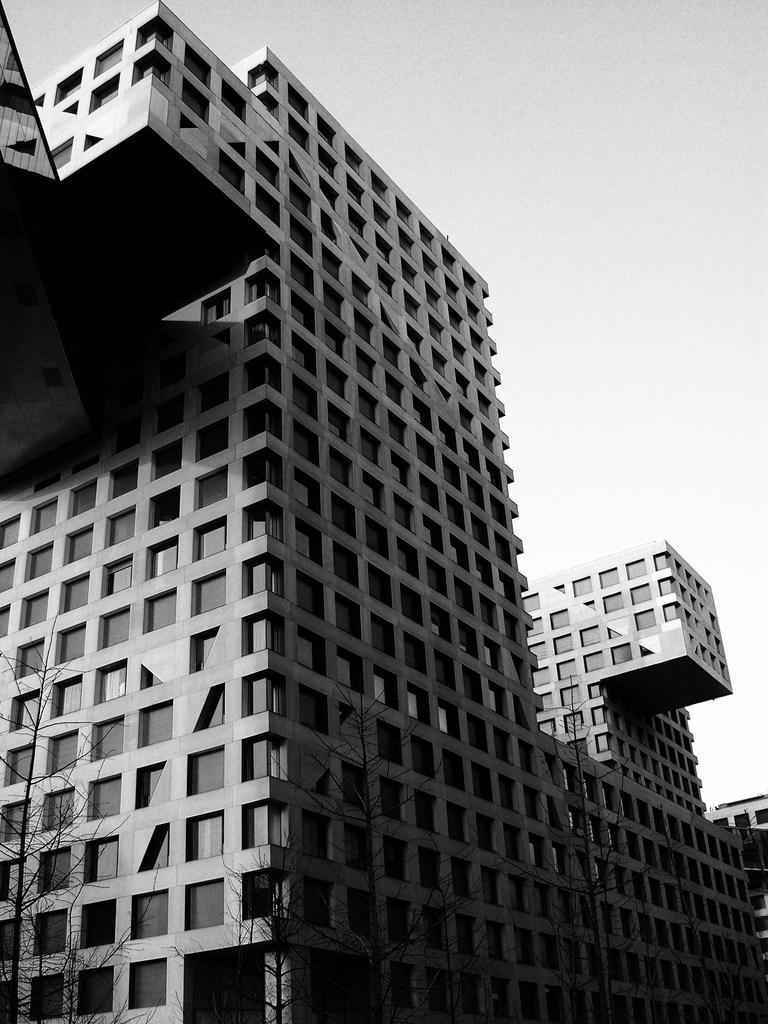What type of structure is present in the image? There is a building in the image. What can be seen at the bottom of the image? There are trees at the bottom of the image. What is visible in the background of the image? The sky is visible in the background of the image. What type of train can be seen passing by the building in the image? There is no train present in the image; it only features a building, trees, and the sky. 